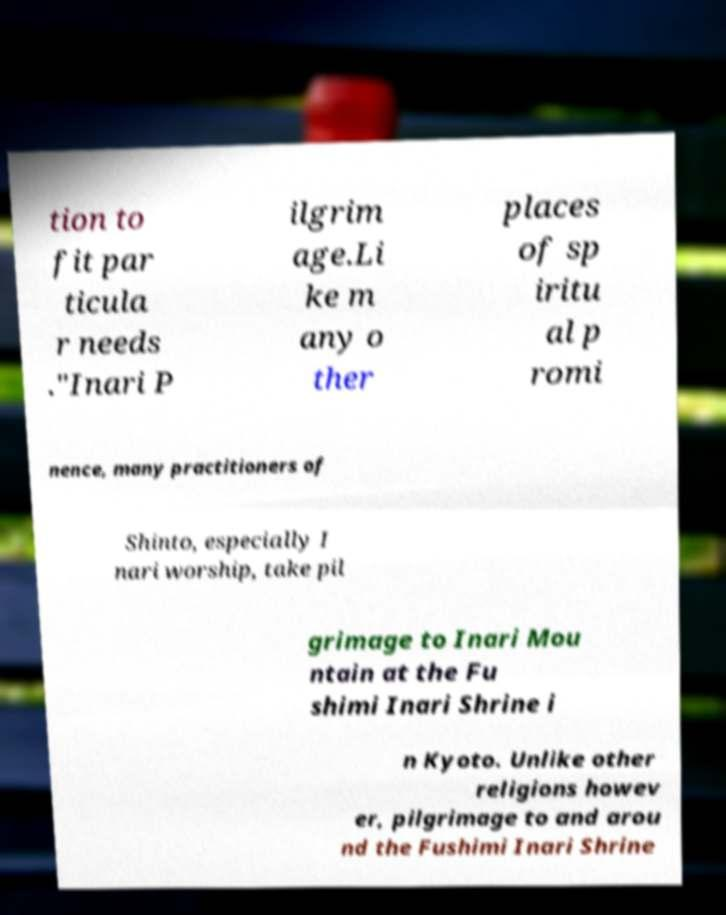Can you read and provide the text displayed in the image?This photo seems to have some interesting text. Can you extract and type it out for me? tion to fit par ticula r needs ."Inari P ilgrim age.Li ke m any o ther places of sp iritu al p romi nence, many practitioners of Shinto, especially I nari worship, take pil grimage to Inari Mou ntain at the Fu shimi Inari Shrine i n Kyoto. Unlike other religions howev er, pilgrimage to and arou nd the Fushimi Inari Shrine 